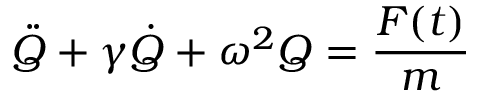Convert formula to latex. <formula><loc_0><loc_0><loc_500><loc_500>\ddot { Q } + \gamma \dot { Q } + \omega ^ { 2 } Q = \frac { F ( t ) } { m }</formula> 